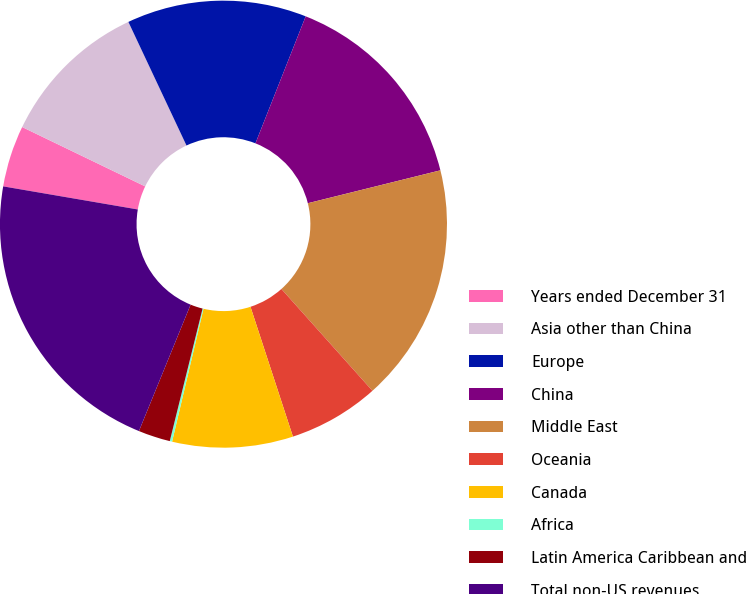<chart> <loc_0><loc_0><loc_500><loc_500><pie_chart><fcel>Years ended December 31<fcel>Asia other than China<fcel>Europe<fcel>China<fcel>Middle East<fcel>Oceania<fcel>Canada<fcel>Africa<fcel>Latin America Caribbean and<fcel>Total non-US revenues<nl><fcel>4.45%<fcel>10.85%<fcel>12.99%<fcel>15.13%<fcel>17.26%<fcel>6.58%<fcel>8.72%<fcel>0.17%<fcel>2.31%<fcel>21.53%<nl></chart> 